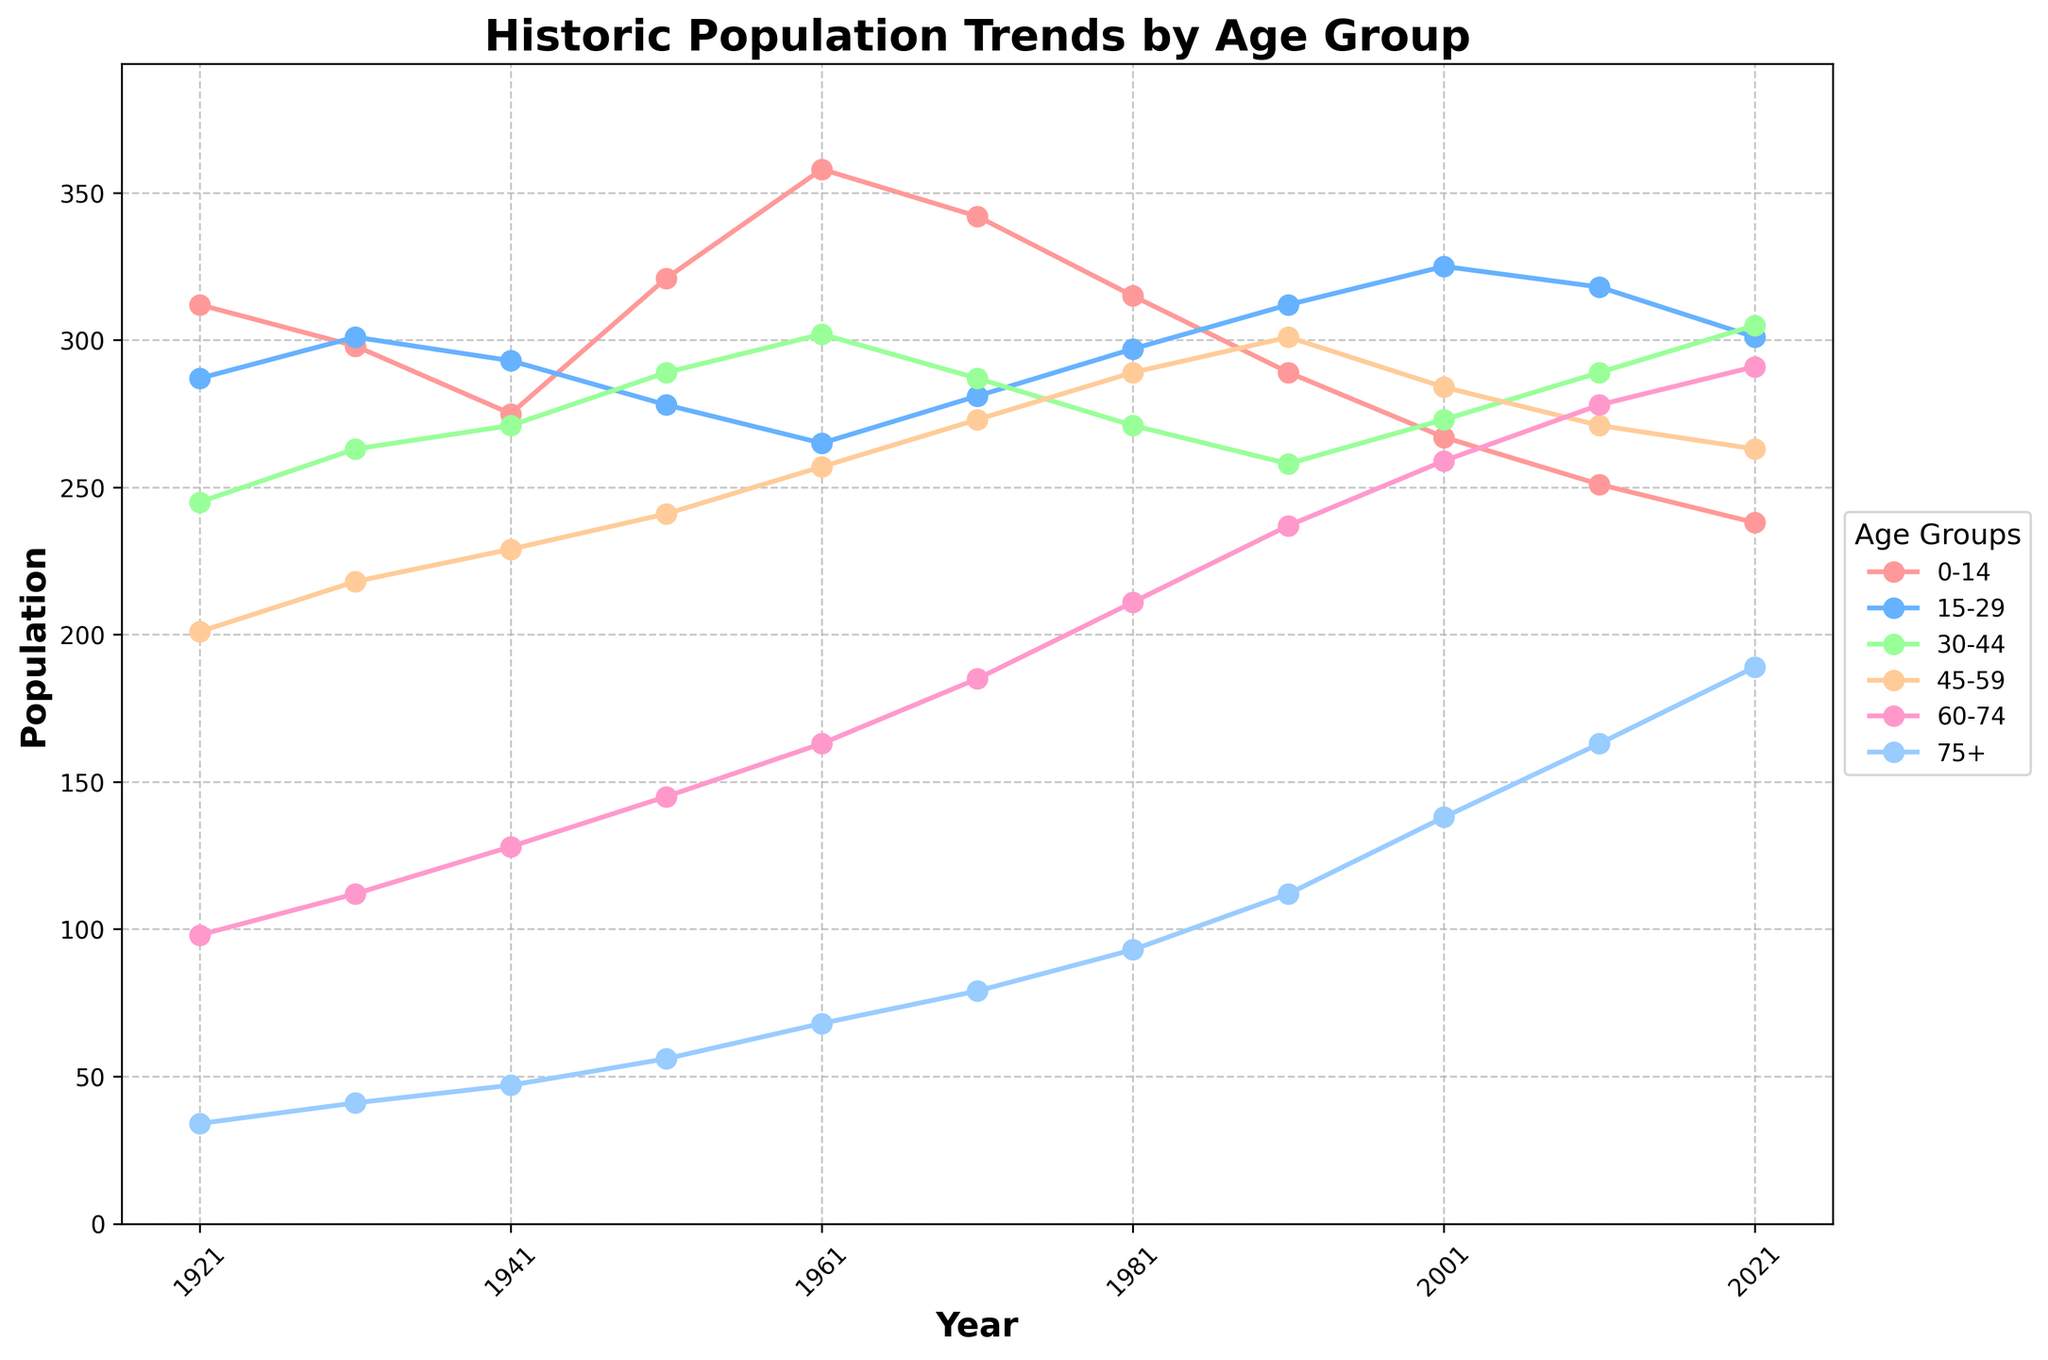Which age group had the most significant population increase between 1921 and 2021? Look at the population numbers for each age group in 1921 and 2021, then subtract the earlier number from the later one. The '75+' group increased from 34 in 1921 to 189 in 2021, an increase of 155. No other group has a larger increase.
Answer: 75+ Which age group had the highest population in 2021? Check the population numbers for each age group in 2021. The '60-74' age group has the highest value with 291.
Answer: 60-74 How did the population of the '0-14' age group change from 1921 to 2021? Refer to the plot and compare the population numbers of the '0-14' age group in 1921 and 2021. The population decreased from 312 in 1921 to 238 in 2021.
Answer: Decreased Which two age groups had nearly equal populations in 1971? Check the population numbers for each age group in 1971. The '30-44' age group had 287, and the '45-59' age group had 273, which are close to each other.
Answer: 30-44 and 45-59 What is the trend for the '15-29' age group over the years? Look at the '15-29' line on the plot to determine the general direction over the years. The population has slightly fluctuated but generally remained steady with a slight upward trend towards the end.
Answer: Slightly upward In which decade did the '60-74' age group see the highest increase? By analyzing the line for '60-74', determine the decade with the steepest slope. The 1981 to 1991 period shows a significant rise from 211 to 237.
Answer: 1981 to 1991 What is the average population for the '30-44' age group during the decades provided? Add the population numbers for the '30-44' age group across all years and divide by the number of decades. (245 + 263 + 271 + 289 + 302 + 287 + 271 + 258 + 273 + 289 + 305) / 11 = 279
Answer: 279 How does the population trend of the '75+' age group compare with the '0-14' age group over the century? Compare the slopes of the two lines. The '75+' age group shows a steady increase, while the '0-14' age group shows a decreasing trend.
Answer: '75+' increased, '0-14' decreased 